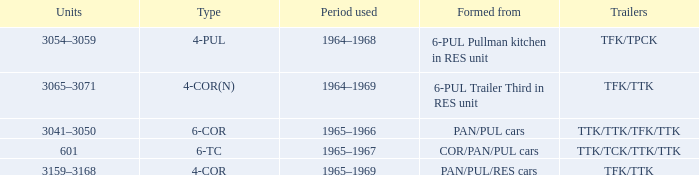Could you parse the entire table? {'header': ['Units', 'Type', 'Period used', 'Formed from', 'Trailers'], 'rows': [['3054–3059', '4-PUL', '1964–1968', '6-PUL Pullman kitchen in RES unit', 'TFK/TPCK'], ['3065–3071', '4-COR(N)', '1964–1969', '6-PUL Trailer Third in RES unit', 'TFK/TTK'], ['3041–3050', '6-COR', '1965–1966', 'PAN/PUL cars', 'TTK/TTK/TFK/TTK'], ['601', '6-TC', '1965–1967', 'COR/PAN/PUL cars', 'TTK/TCK/TTK/TTK'], ['3159–3168', '4-COR', '1965–1969', 'PAN/PUL/RES cars', 'TFK/TTK']]} What is the structure called that has a 4-cornered type? PAN/PUL/RES cars. 